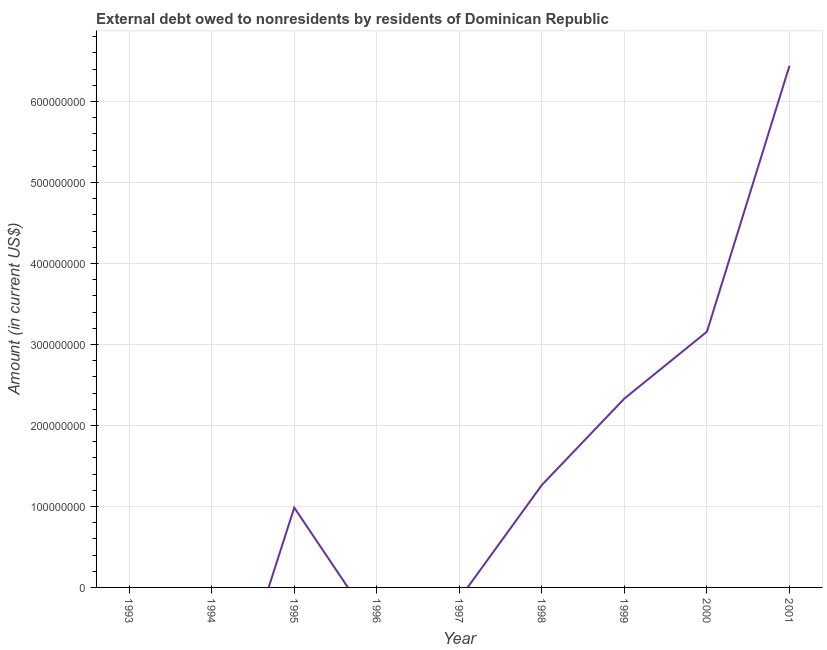What is the debt in 1995?
Offer a very short reply. 9.85e+07. Across all years, what is the maximum debt?
Make the answer very short. 6.44e+08. In which year was the debt maximum?
Keep it short and to the point. 2001. What is the sum of the debt?
Give a very brief answer. 1.42e+09. What is the difference between the debt in 1995 and 1998?
Your response must be concise. -2.79e+07. What is the average debt per year?
Give a very brief answer. 1.58e+08. What is the median debt?
Provide a short and direct response. 9.85e+07. In how many years, is the debt greater than 400000000 US$?
Give a very brief answer. 1. Is the debt in 1999 less than that in 2001?
Offer a very short reply. Yes. Is the difference between the debt in 1998 and 1999 greater than the difference between any two years?
Your answer should be compact. No. What is the difference between the highest and the second highest debt?
Your answer should be very brief. 3.28e+08. Is the sum of the debt in 1999 and 2001 greater than the maximum debt across all years?
Your answer should be compact. Yes. What is the difference between the highest and the lowest debt?
Keep it short and to the point. 6.44e+08. Does the debt monotonically increase over the years?
Ensure brevity in your answer.  No. How many lines are there?
Give a very brief answer. 1. How many years are there in the graph?
Your answer should be very brief. 9. What is the title of the graph?
Keep it short and to the point. External debt owed to nonresidents by residents of Dominican Republic. What is the Amount (in current US$) of 1994?
Keep it short and to the point. 0. What is the Amount (in current US$) in 1995?
Ensure brevity in your answer.  9.85e+07. What is the Amount (in current US$) of 1997?
Offer a terse response. 0. What is the Amount (in current US$) in 1998?
Your answer should be very brief. 1.26e+08. What is the Amount (in current US$) of 1999?
Your response must be concise. 2.33e+08. What is the Amount (in current US$) in 2000?
Offer a terse response. 3.16e+08. What is the Amount (in current US$) of 2001?
Your answer should be compact. 6.44e+08. What is the difference between the Amount (in current US$) in 1995 and 1998?
Your answer should be compact. -2.79e+07. What is the difference between the Amount (in current US$) in 1995 and 1999?
Your response must be concise. -1.35e+08. What is the difference between the Amount (in current US$) in 1995 and 2000?
Your answer should be compact. -2.17e+08. What is the difference between the Amount (in current US$) in 1995 and 2001?
Offer a terse response. -5.45e+08. What is the difference between the Amount (in current US$) in 1998 and 1999?
Ensure brevity in your answer.  -1.07e+08. What is the difference between the Amount (in current US$) in 1998 and 2000?
Provide a succinct answer. -1.89e+08. What is the difference between the Amount (in current US$) in 1998 and 2001?
Your answer should be compact. -5.18e+08. What is the difference between the Amount (in current US$) in 1999 and 2000?
Provide a succinct answer. -8.25e+07. What is the difference between the Amount (in current US$) in 1999 and 2001?
Give a very brief answer. -4.11e+08. What is the difference between the Amount (in current US$) in 2000 and 2001?
Provide a succinct answer. -3.28e+08. What is the ratio of the Amount (in current US$) in 1995 to that in 1998?
Offer a terse response. 0.78. What is the ratio of the Amount (in current US$) in 1995 to that in 1999?
Give a very brief answer. 0.42. What is the ratio of the Amount (in current US$) in 1995 to that in 2000?
Offer a very short reply. 0.31. What is the ratio of the Amount (in current US$) in 1995 to that in 2001?
Offer a very short reply. 0.15. What is the ratio of the Amount (in current US$) in 1998 to that in 1999?
Ensure brevity in your answer.  0.54. What is the ratio of the Amount (in current US$) in 1998 to that in 2000?
Give a very brief answer. 0.4. What is the ratio of the Amount (in current US$) in 1998 to that in 2001?
Offer a very short reply. 0.2. What is the ratio of the Amount (in current US$) in 1999 to that in 2000?
Keep it short and to the point. 0.74. What is the ratio of the Amount (in current US$) in 1999 to that in 2001?
Offer a very short reply. 0.36. What is the ratio of the Amount (in current US$) in 2000 to that in 2001?
Your answer should be compact. 0.49. 